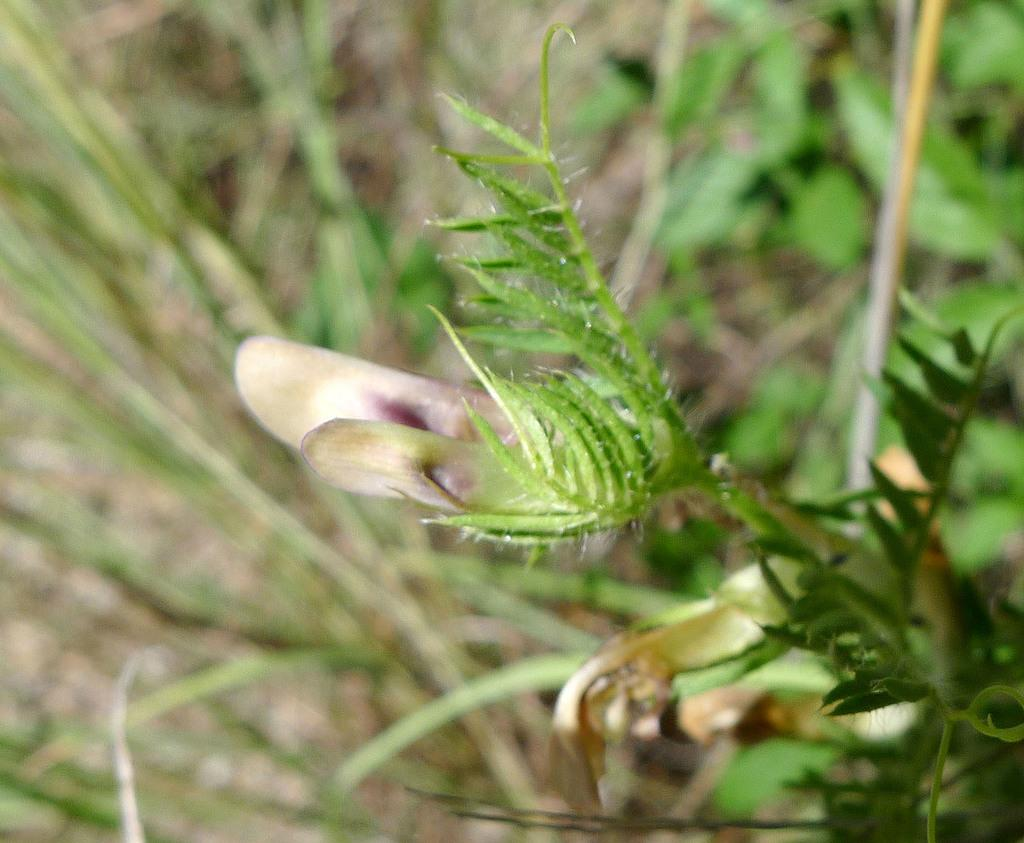What is the main subject in the center of the image? There is a flower plant in the center of the image. What can be seen in the background of the image? There is greenery in the background of the image. How many chickens are present in the image? There are no chickens present in the image; it features a flower plant and greenery. What type of office furniture can be seen in the image? There is no office furniture present in the image; it features a flower plant and greenery. 